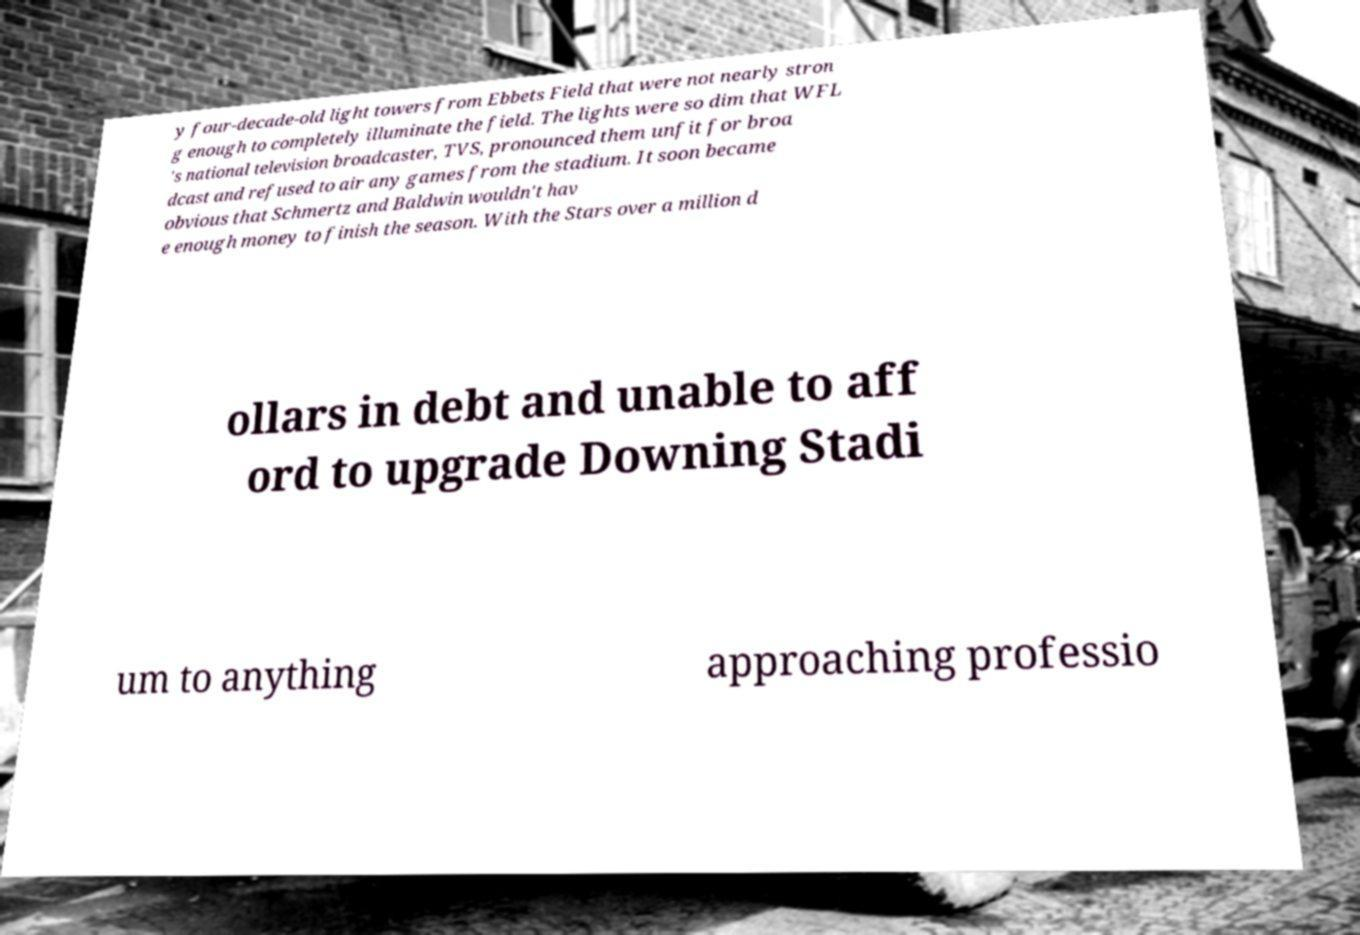Can you read and provide the text displayed in the image?This photo seems to have some interesting text. Can you extract and type it out for me? y four-decade-old light towers from Ebbets Field that were not nearly stron g enough to completely illuminate the field. The lights were so dim that WFL 's national television broadcaster, TVS, pronounced them unfit for broa dcast and refused to air any games from the stadium. It soon became obvious that Schmertz and Baldwin wouldn't hav e enough money to finish the season. With the Stars over a million d ollars in debt and unable to aff ord to upgrade Downing Stadi um to anything approaching professio 